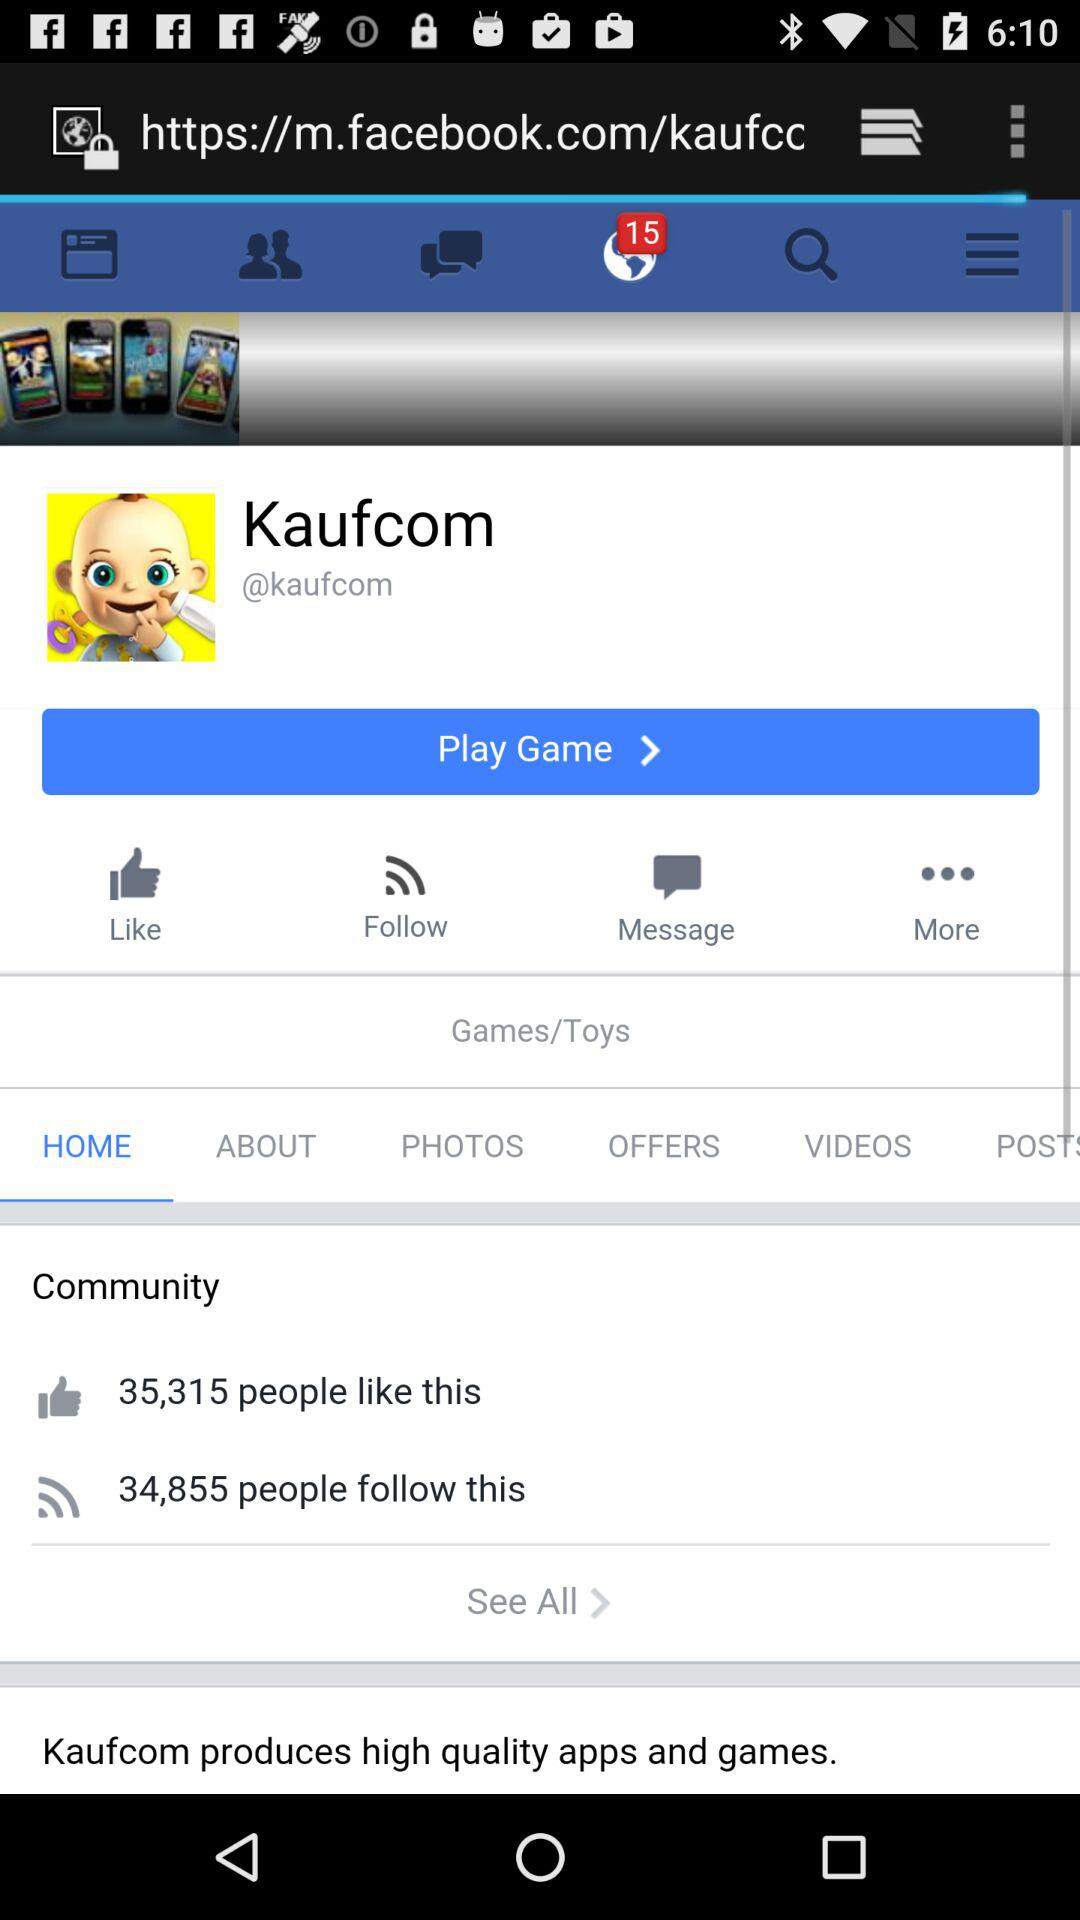What is the game name given on the screen? The game name is "Kaufcom". 